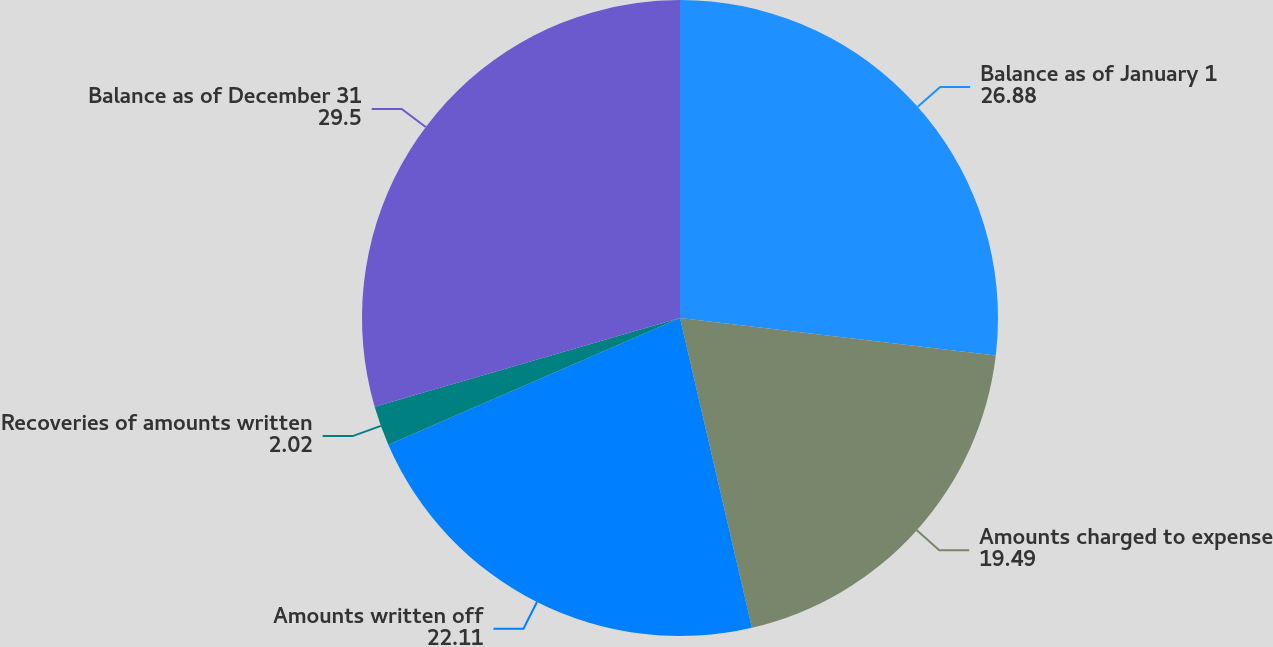Convert chart to OTSL. <chart><loc_0><loc_0><loc_500><loc_500><pie_chart><fcel>Balance as of January 1<fcel>Amounts charged to expense<fcel>Amounts written off<fcel>Recoveries of amounts written<fcel>Balance as of December 31<nl><fcel>26.88%<fcel>19.49%<fcel>22.11%<fcel>2.02%<fcel>29.5%<nl></chart> 